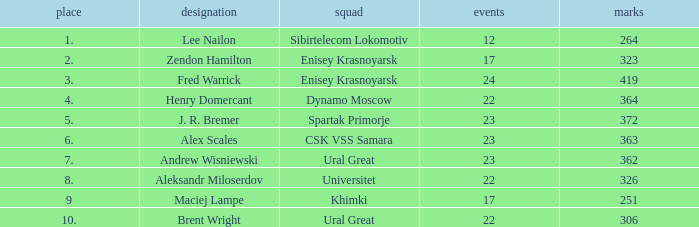What was the game with a rank higher than 2 and a name of zendon hamilton? None. 